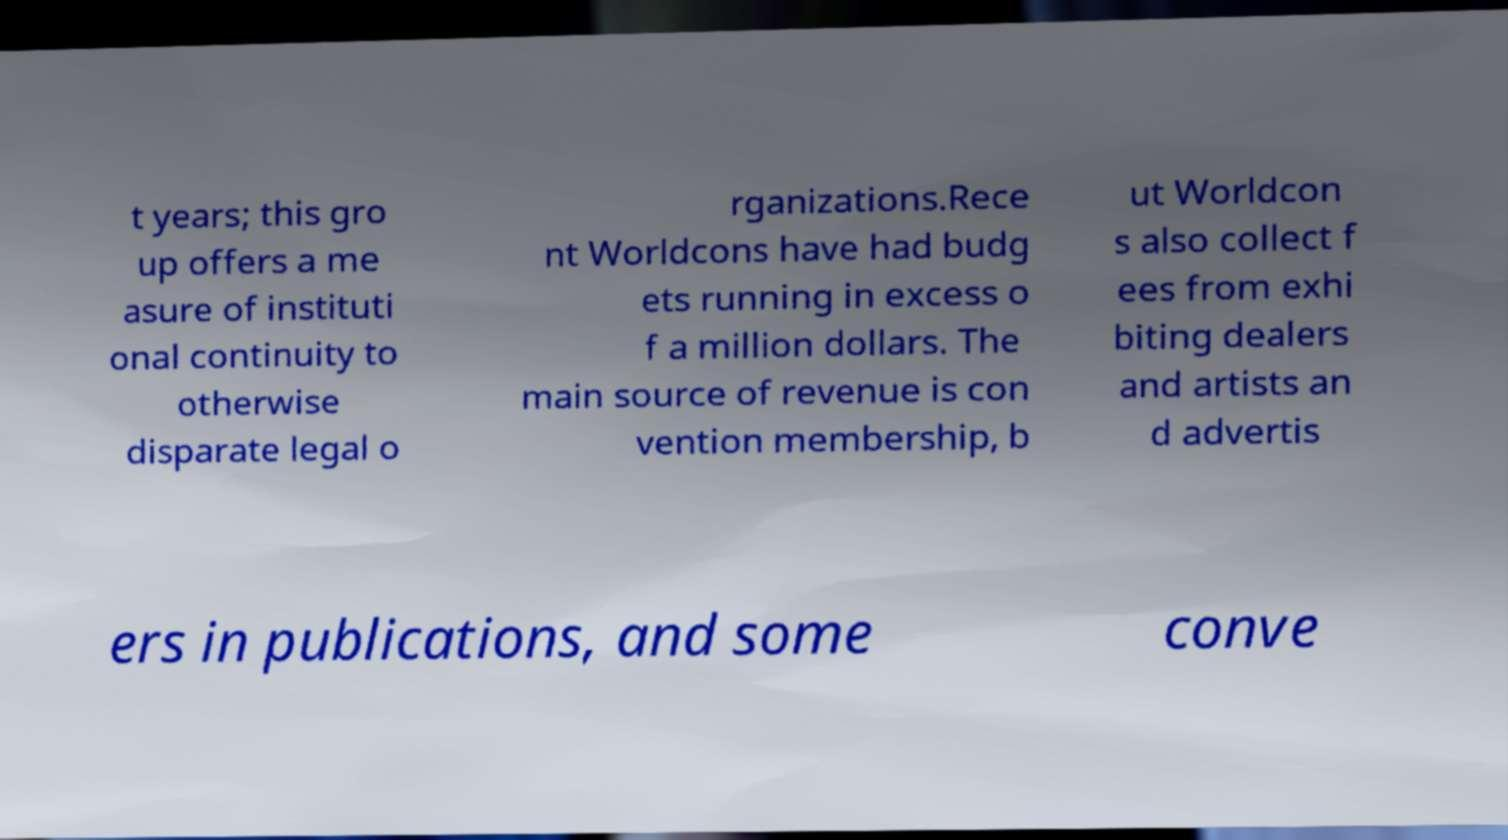There's text embedded in this image that I need extracted. Can you transcribe it verbatim? t years; this gro up offers a me asure of instituti onal continuity to otherwise disparate legal o rganizations.Rece nt Worldcons have had budg ets running in excess o f a million dollars. The main source of revenue is con vention membership, b ut Worldcon s also collect f ees from exhi biting dealers and artists an d advertis ers in publications, and some conve 